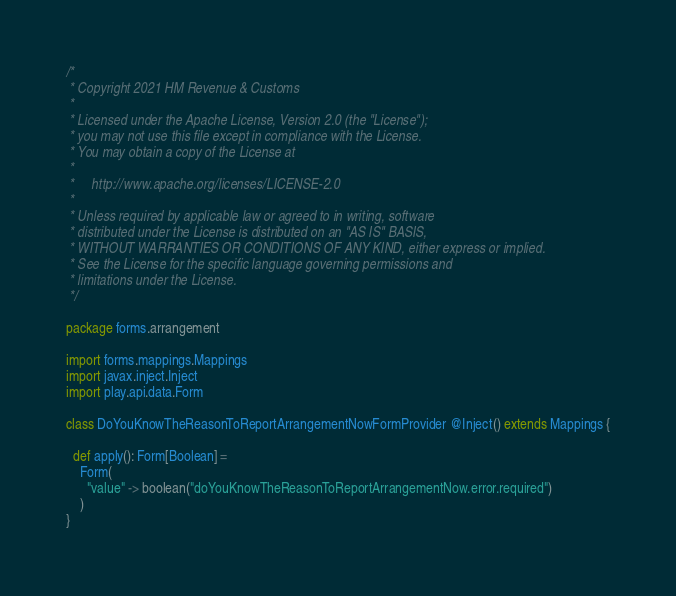<code> <loc_0><loc_0><loc_500><loc_500><_Scala_>/*
 * Copyright 2021 HM Revenue & Customs
 *
 * Licensed under the Apache License, Version 2.0 (the "License");
 * you may not use this file except in compliance with the License.
 * You may obtain a copy of the License at
 *
 *     http://www.apache.org/licenses/LICENSE-2.0
 *
 * Unless required by applicable law or agreed to in writing, software
 * distributed under the License is distributed on an "AS IS" BASIS,
 * WITHOUT WARRANTIES OR CONDITIONS OF ANY KIND, either express or implied.
 * See the License for the specific language governing permissions and
 * limitations under the License.
 */

package forms.arrangement

import forms.mappings.Mappings
import javax.inject.Inject
import play.api.data.Form

class DoYouKnowTheReasonToReportArrangementNowFormProvider @Inject() extends Mappings {

  def apply(): Form[Boolean] =
    Form(
      "value" -> boolean("doYouKnowTheReasonToReportArrangementNow.error.required")
    )
}
</code> 